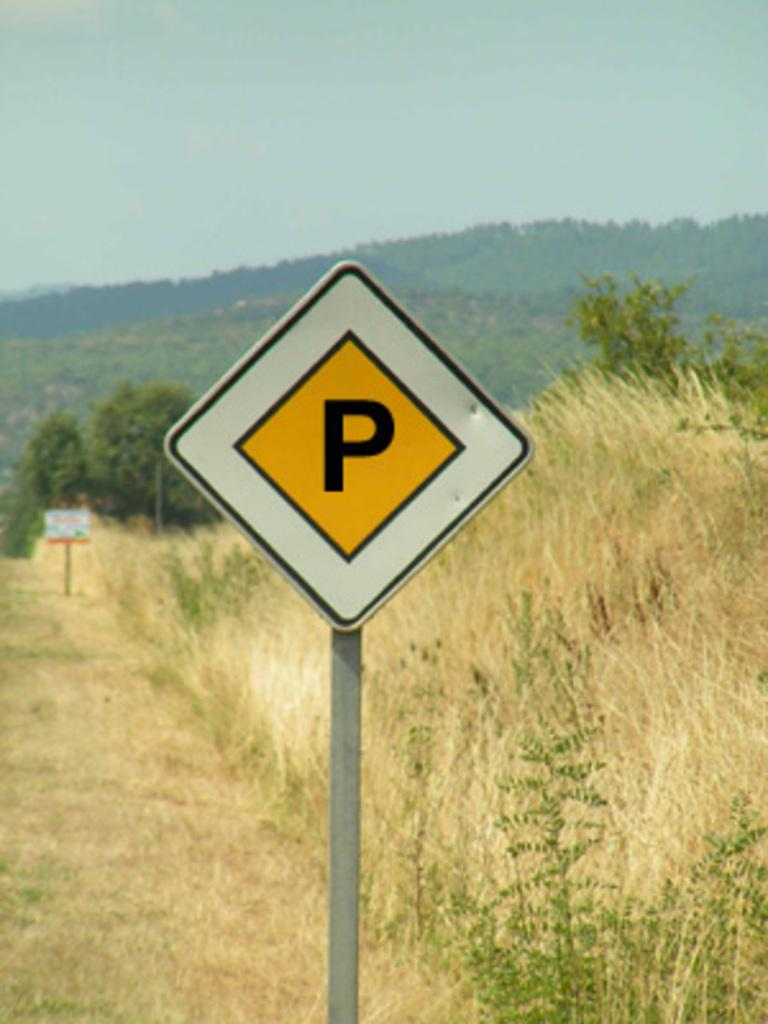What is the main object in the center of the image? There is a sign board in the center of the image. What can be seen in the background of the image? There are trees, hills, and the sky visible in the background of the image. What type of vegetation is present at the bottom of the image? There is grass at the bottom of the image. What type of behavior is exhibited by the airplane in the image? There is no airplane present in the image, so it is not possible to comment on its behavior. 